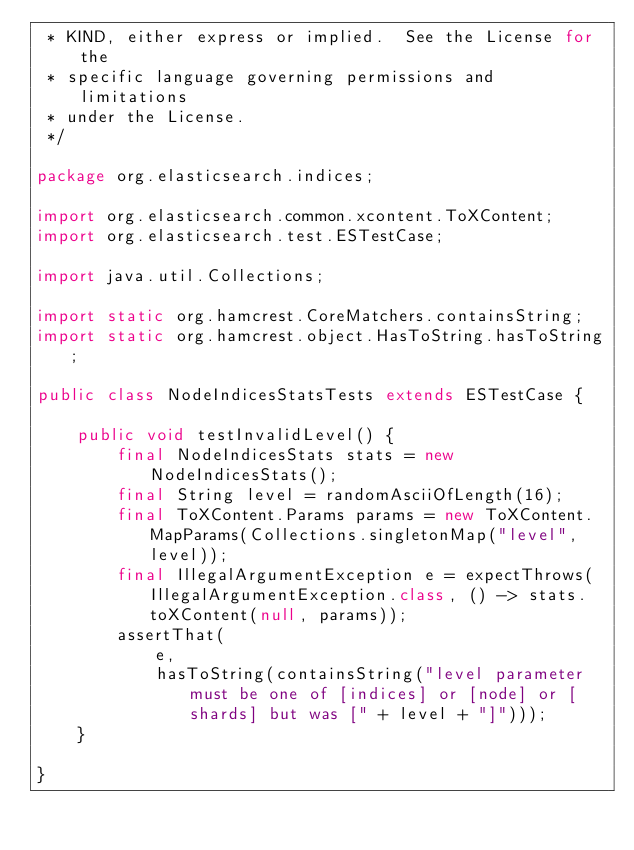<code> <loc_0><loc_0><loc_500><loc_500><_Java_> * KIND, either express or implied.  See the License for the
 * specific language governing permissions and limitations
 * under the License.
 */

package org.elasticsearch.indices;

import org.elasticsearch.common.xcontent.ToXContent;
import org.elasticsearch.test.ESTestCase;

import java.util.Collections;

import static org.hamcrest.CoreMatchers.containsString;
import static org.hamcrest.object.HasToString.hasToString;

public class NodeIndicesStatsTests extends ESTestCase {

    public void testInvalidLevel() {
        final NodeIndicesStats stats = new NodeIndicesStats();
        final String level = randomAsciiOfLength(16);
        final ToXContent.Params params = new ToXContent.MapParams(Collections.singletonMap("level", level));
        final IllegalArgumentException e = expectThrows(IllegalArgumentException.class, () -> stats.toXContent(null, params));
        assertThat(
            e,
            hasToString(containsString("level parameter must be one of [indices] or [node] or [shards] but was [" + level + "]")));
    }

}
</code> 